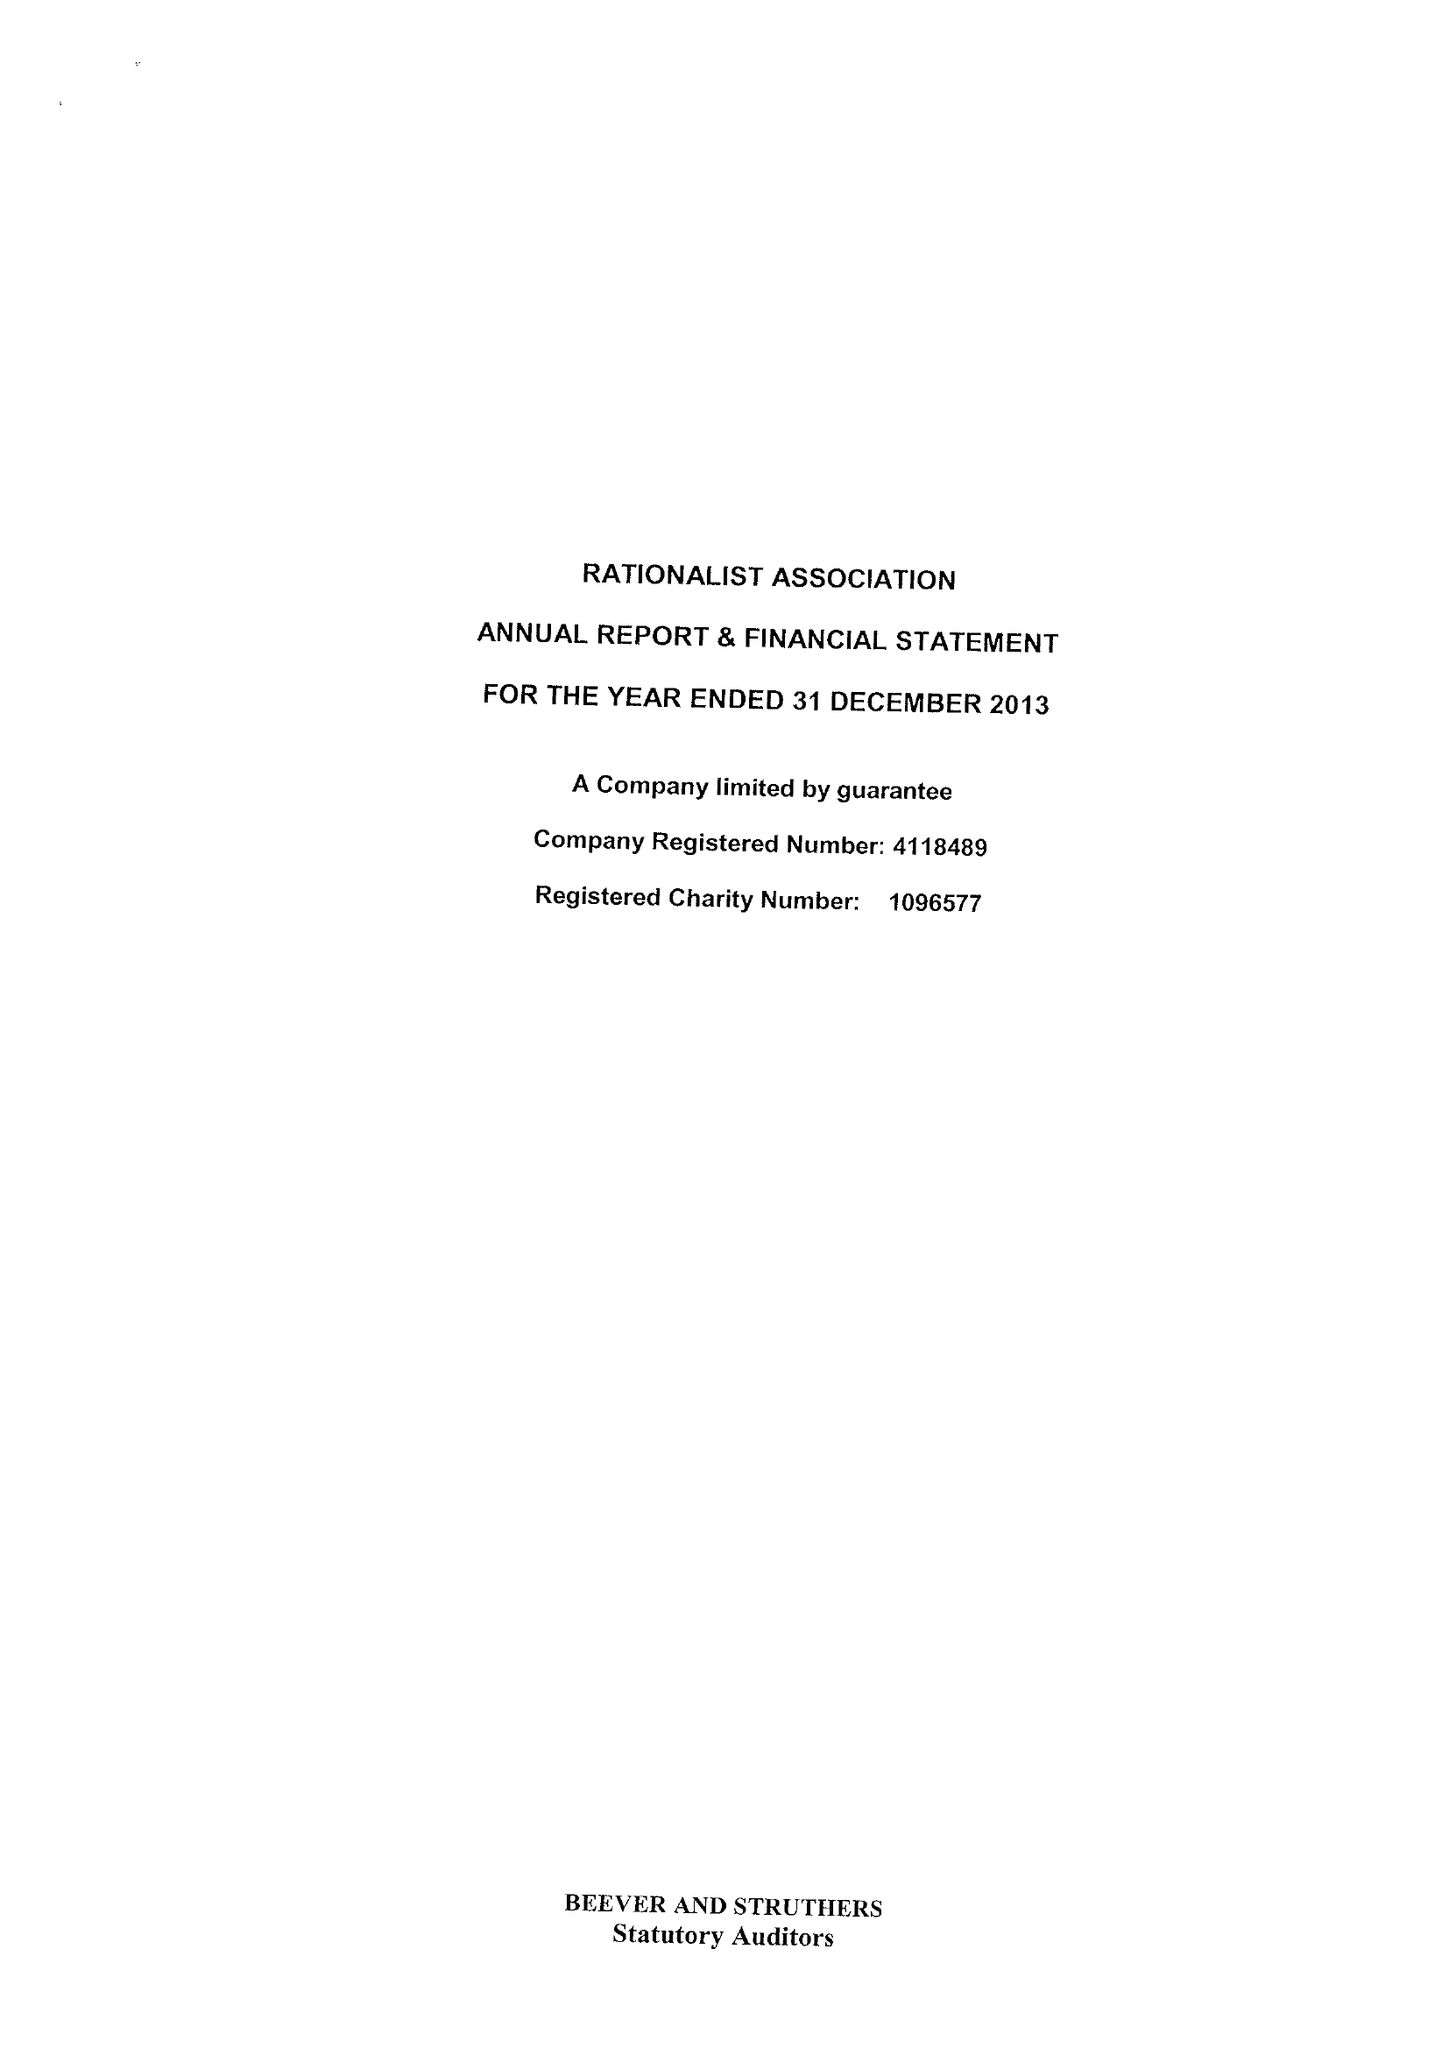What is the value for the report_date?
Answer the question using a single word or phrase. 2013-12-31 